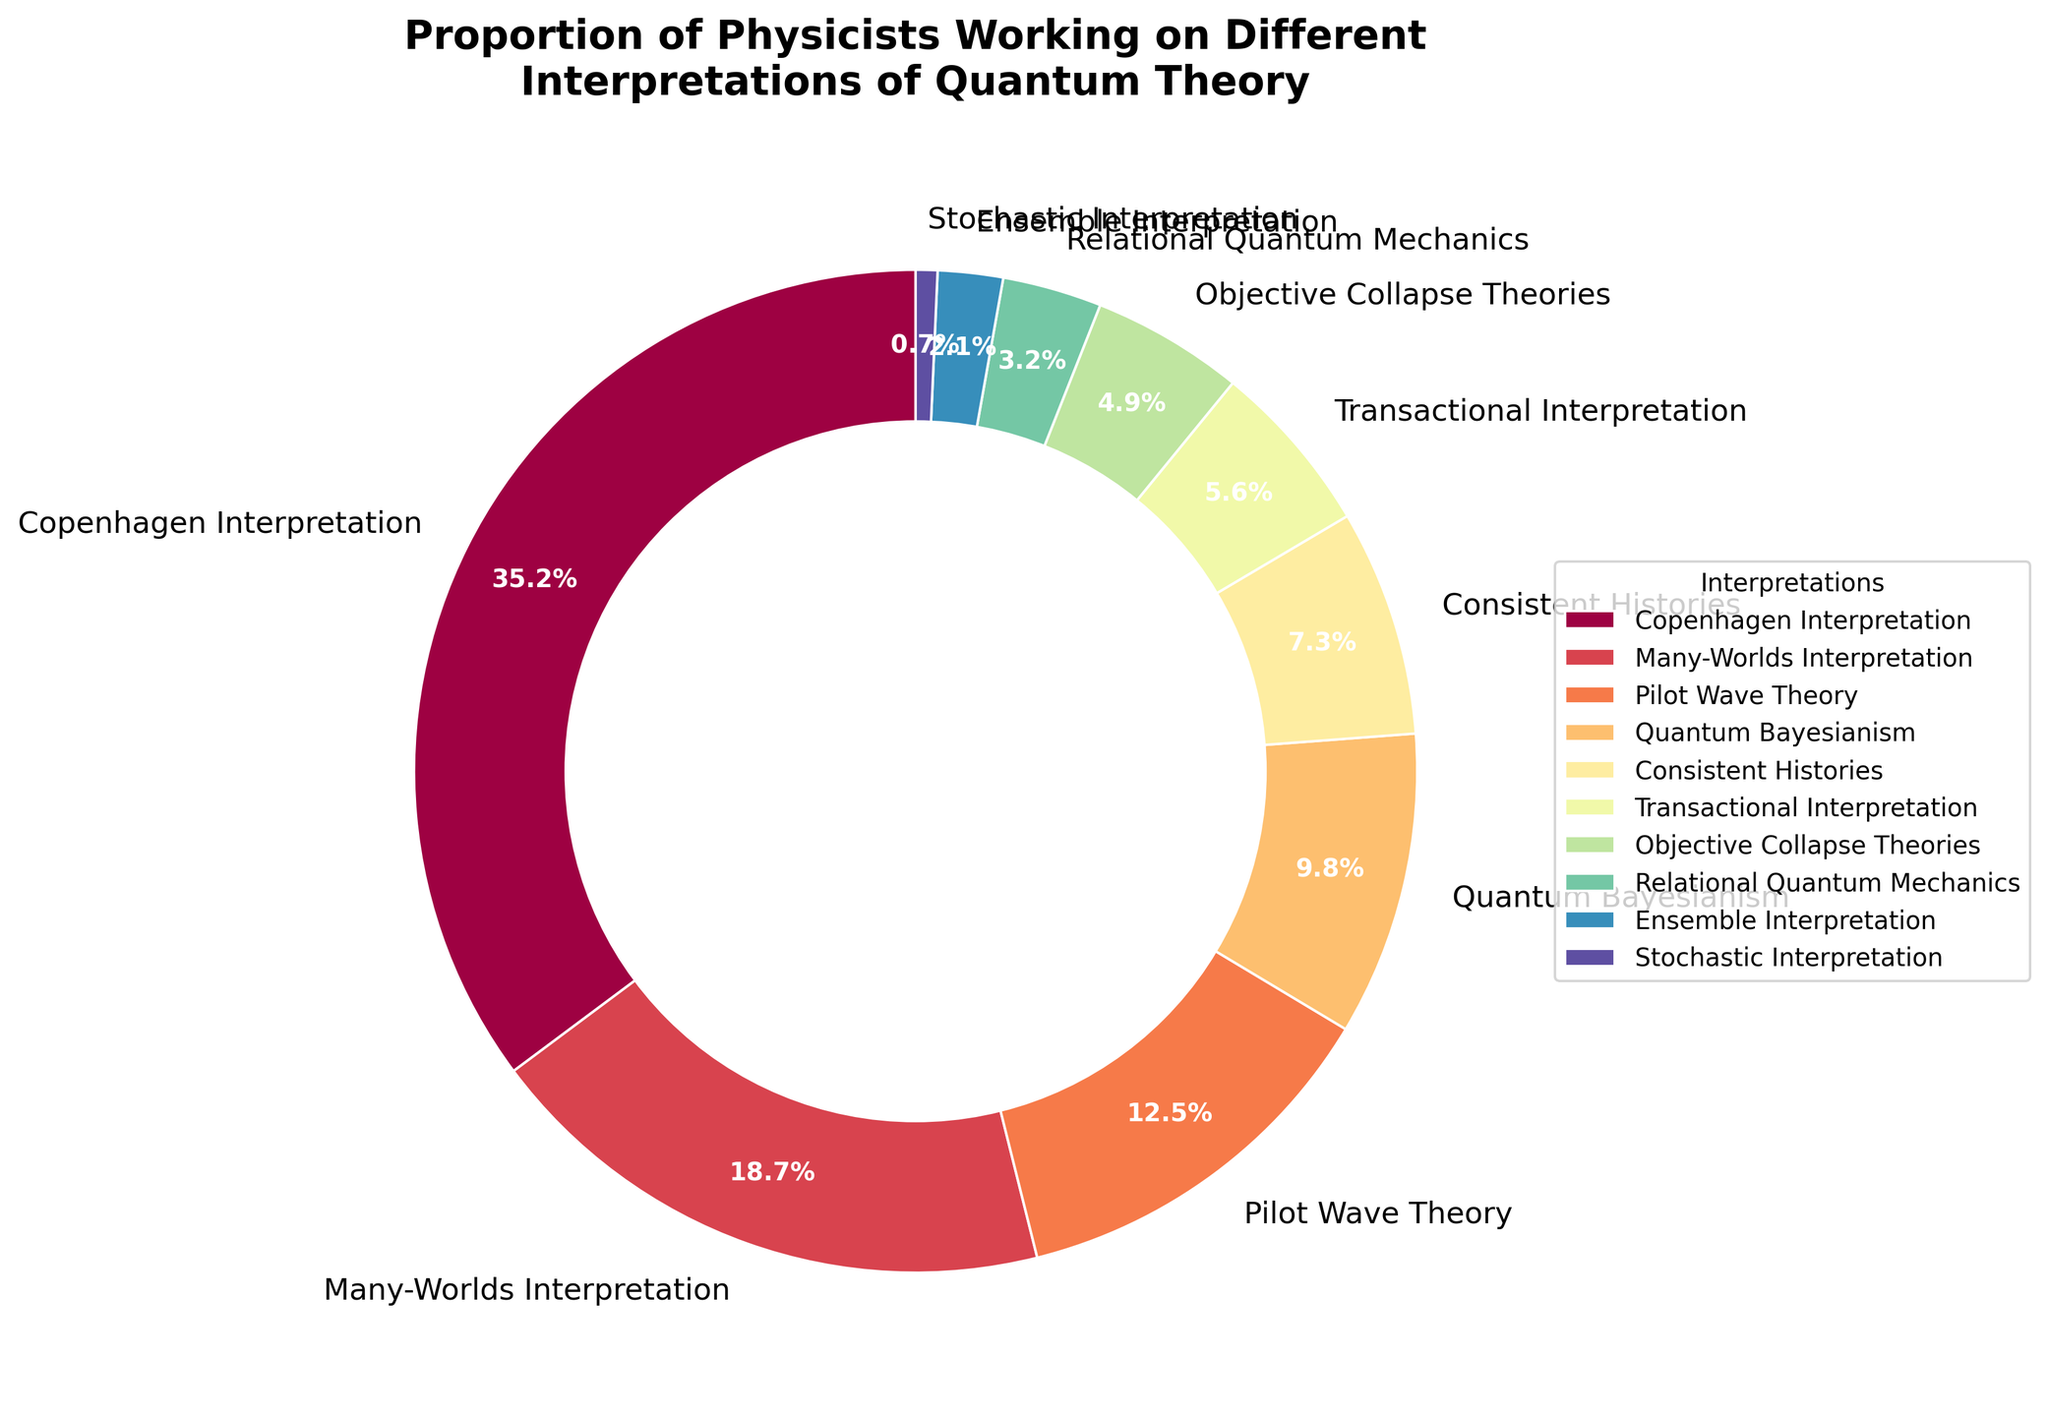What is the proportion of physicists working on the Copenhagen Interpretation? Look at the slice labeled "Copenhagen Interpretation" on the pie chart. The percentage is displayed on the slice.
Answer: 35.2% Which interpretation has the smallest proportion of physicists working on it? Compare each slice's percentage to find the smallest value.
Answer: Stochastic Interpretation Is the proportion of physicists working on the Many-Worlds Interpretation greater than those working on the Pilot Wave Theory? Look at the slices labeled "Many-Worlds Interpretation" and "Pilot Wave Theory". Compare the percentages (18.7% vs. 12.5%).
Answer: Yes What is the combined proportion of physicists working on the Quantum Bayesianism and Consistent Histories interpretations? Sum the percentages of Quantum Bayesianism (9.8%) and Consistent Histories (7.3%). 9.8% + 7.3% = 17.1%
Answer: 17.1% How does the proportion of physicists working on Objective Collapse Theories compare to those working on the Relational Quantum Mechanics? Compare the percentages of Objective Collapse Theories (4.9%) and Relational Quantum Mechanics (3.2%).
Answer: Higher What is the average proportion of physicists in the bottom three interpretations by percentage? Identify the bottom three interpretations (Stochastic Interpretation, Ensemble Interpretation, Relational Quantum Mechanics) and their percentages. Find the average: (0.7% + 2.1% + 3.2%) / 3 = 2.0%.
Answer: 2.0% Which interpretation occupies the largest slice in the pie chart? Identify the slice with the largest percentage.
Answer: Copenhagen Interpretation What is the difference in proportions between the Many-Worlds Interpretation and the Objective Collapse Theories? Subtract the percentage of Objective Collapse Theories (4.9%) from Many-Worlds Interpretation (18.7%): 18.7% - 4.9% = 13.8%.
Answer: 13.8% What is the combined proportion of physicists working on interpretations other than the top three? Identify the top three interpretations (Copenhagen Interpretation, Many-Worlds Interpretation, Pilot Wave Theory) and sum their percentages: 35.2% + 18.7% + 12.5% = 66.4%. Subtract this sum from 100%: 100% - 66.4% = 33.6%.
Answer: 33.6% Can you identify the interpretation with a purple slice in the pie chart? The pie chart is color-coded. Identify the interpretation corresponding to the purple slice.
Answer: Transactional Interpretation 